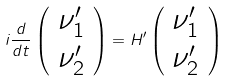<formula> <loc_0><loc_0><loc_500><loc_500>i { \frac { d } { d t } } \left ( \begin{array} { c } \nu _ { 1 } ^ { \prime } \\ \nu _ { 2 } ^ { \prime } \end{array} \right ) = H ^ { \prime } \left ( \begin{array} { c } \nu _ { 1 } ^ { \prime } \\ \nu _ { 2 } ^ { \prime } \end{array} \right )</formula> 